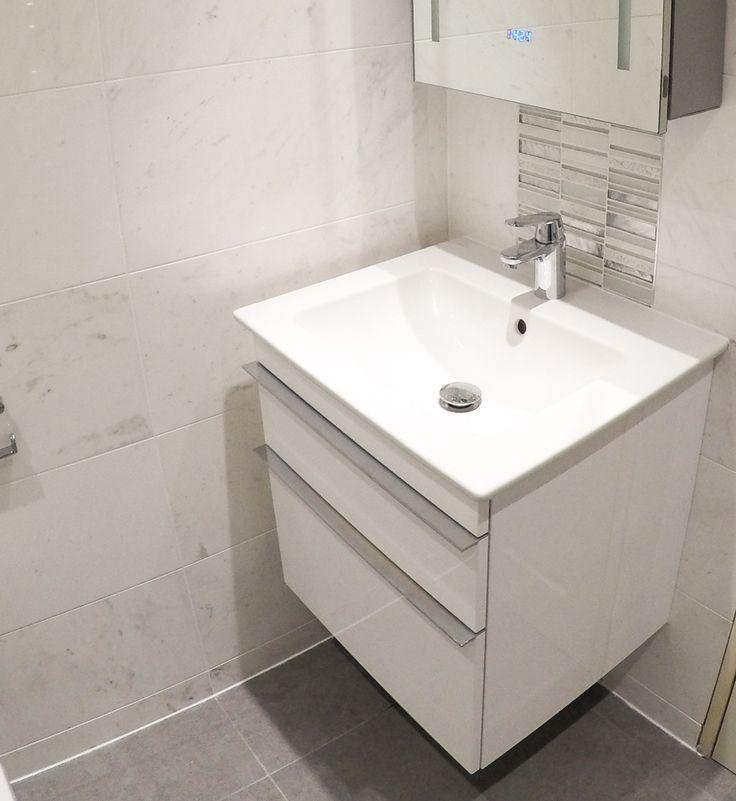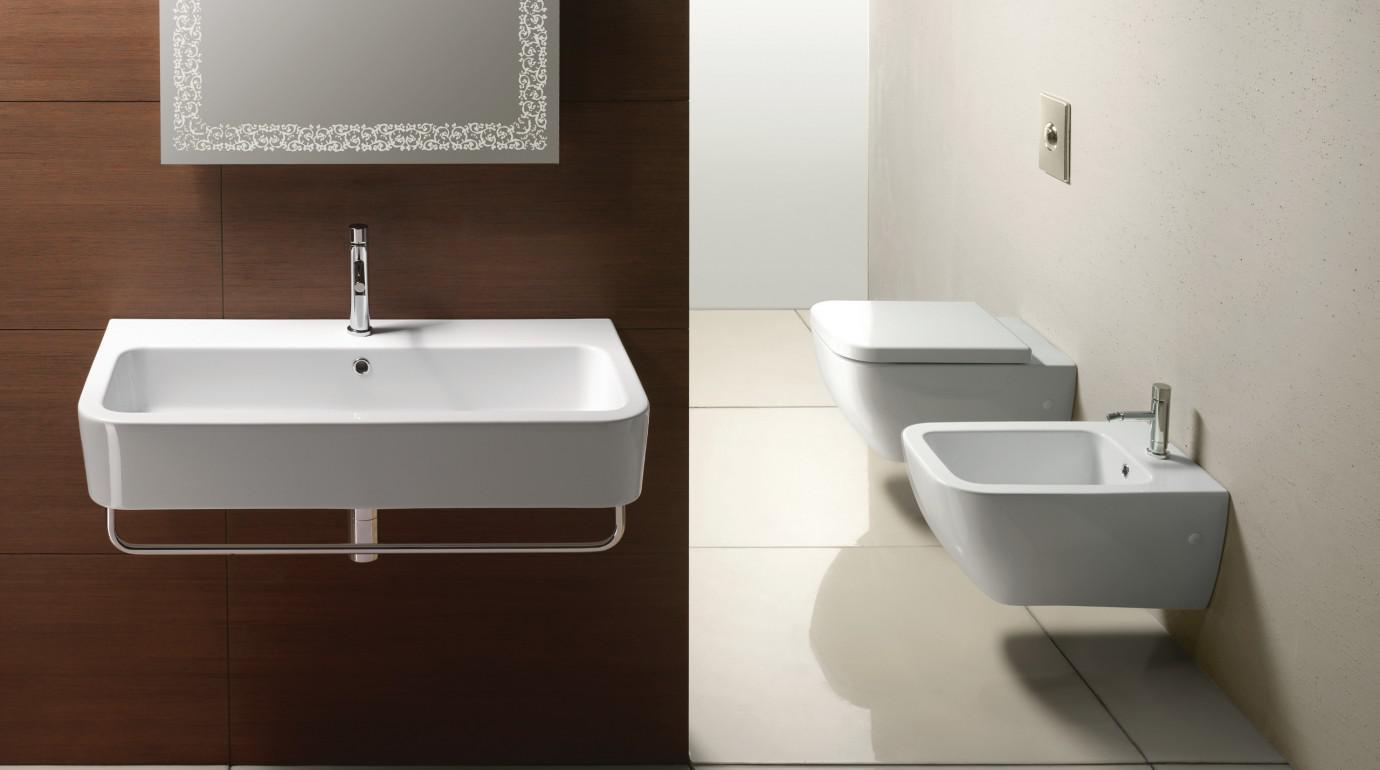The first image is the image on the left, the second image is the image on the right. For the images shown, is this caption "The right image includes a tankless wall-mounted white toilet behind a similarly shaped wall-mounted white sink." true? Answer yes or no. Yes. The first image is the image on the left, the second image is the image on the right. For the images displayed, is the sentence "In one image a sink with chrome faucet and a commode, both white, are mounted side by side on a wall." factually correct? Answer yes or no. Yes. 